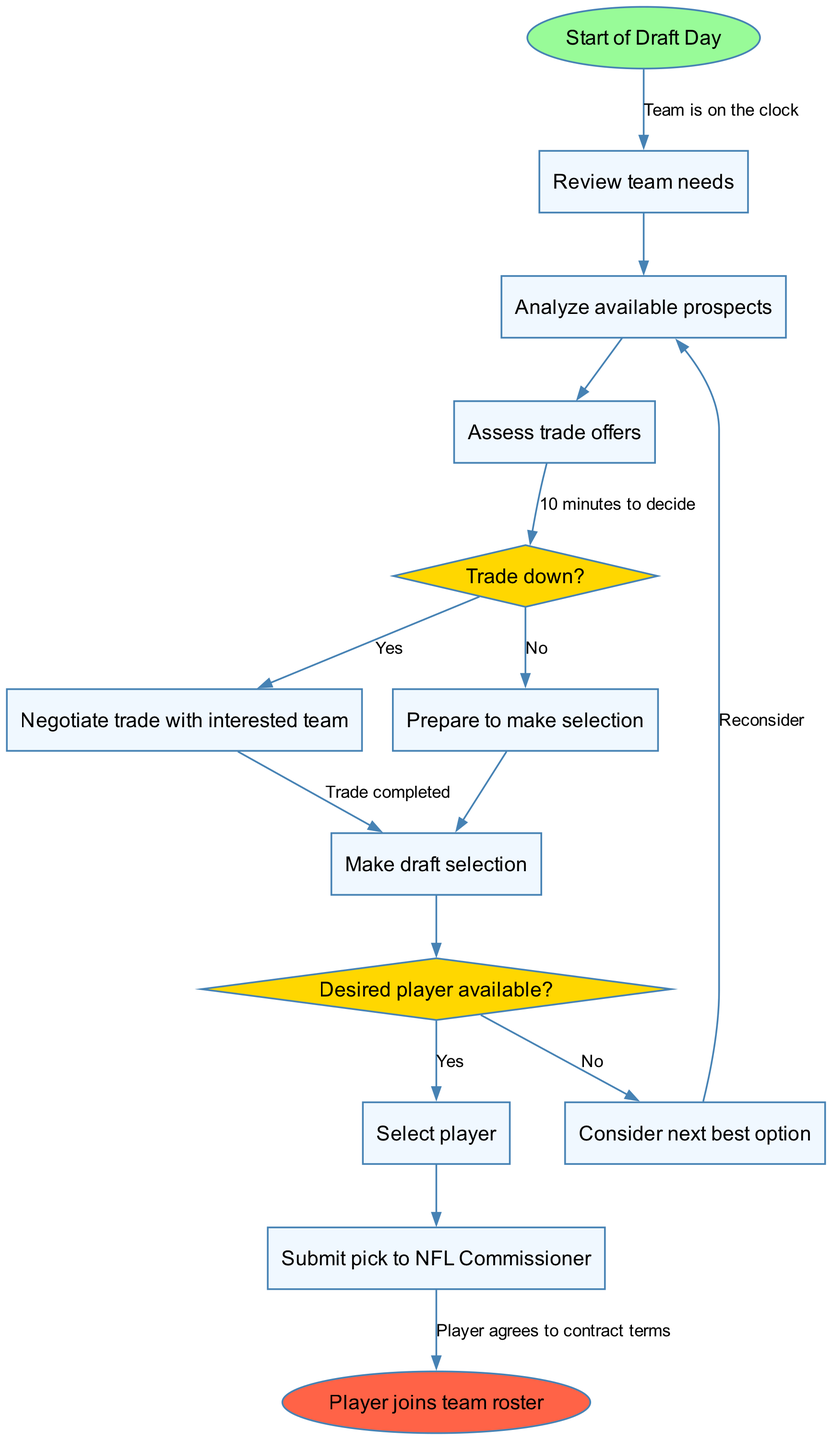What's the first activity in the diagram? The first activity in the diagram is represented by the first rectangular node following the start oval node. It is labeled "Review team needs."
Answer: Review team needs How many decision nodes are there in the diagram? To find the number of decision nodes, we count the diamond-shaped nodes in the diagram. There are two decision nodes labeled by the questions "Trade down?" and "Desired player available?"
Answer: 2 What happens if the desired player is not available? Following the diagram, if the desired player is not available, the flow leads the team to consider the next best option, represented by the corresponding rectangular node.
Answer: Consider next best option What edge connects to the "Make draft selection" activity? The edge connecting to the "Make draft selection" activity comes from the "Trade down?" decision node where the answer is "No," indicating that the team is preparing to make a selection without a trade.
Answer: Prepare to make selection What is the final outcome in the diagram? The final outcome is represented by the end oval node of the diagram, which states that the player joins the team roster.
Answer: Player joins team roster What activity occurs after analyzing available prospects? After analyzing available prospects, the next activity that occurs is assessing trade offers, which is connected by a direct edge.
Answer: Assess trade offers What is the edge label between the start node and the first activity? The edge label connecting the start node to the first activity node is labeled "Team is on the clock," indicating the initiation of the draft process.
Answer: Team is on the clock What decision follows after assessing trade offers? After assessing trade offers, the decision that follows is whether to trade down or not, as denoted by the connection to the decision node labeled "Trade down?"
Answer: Trade down? 